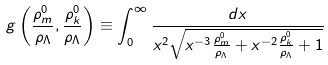<formula> <loc_0><loc_0><loc_500><loc_500>g \left ( \frac { \rho _ { m } ^ { 0 } } { \rho _ { \Lambda } } , \frac { \rho _ { k } ^ { 0 } } { \rho _ { \Lambda } } \right ) \equiv \int _ { 0 } ^ { \infty } { \frac { d x } { { { x ^ { 2 } } \sqrt { { x ^ { - 3 } } \frac { \rho _ { m } ^ { 0 } } { \rho _ { \Lambda } } + { x ^ { - 2 } } \frac { \rho _ { k } ^ { 0 } } { \rho _ { \Lambda } } + 1 } } } }</formula> 